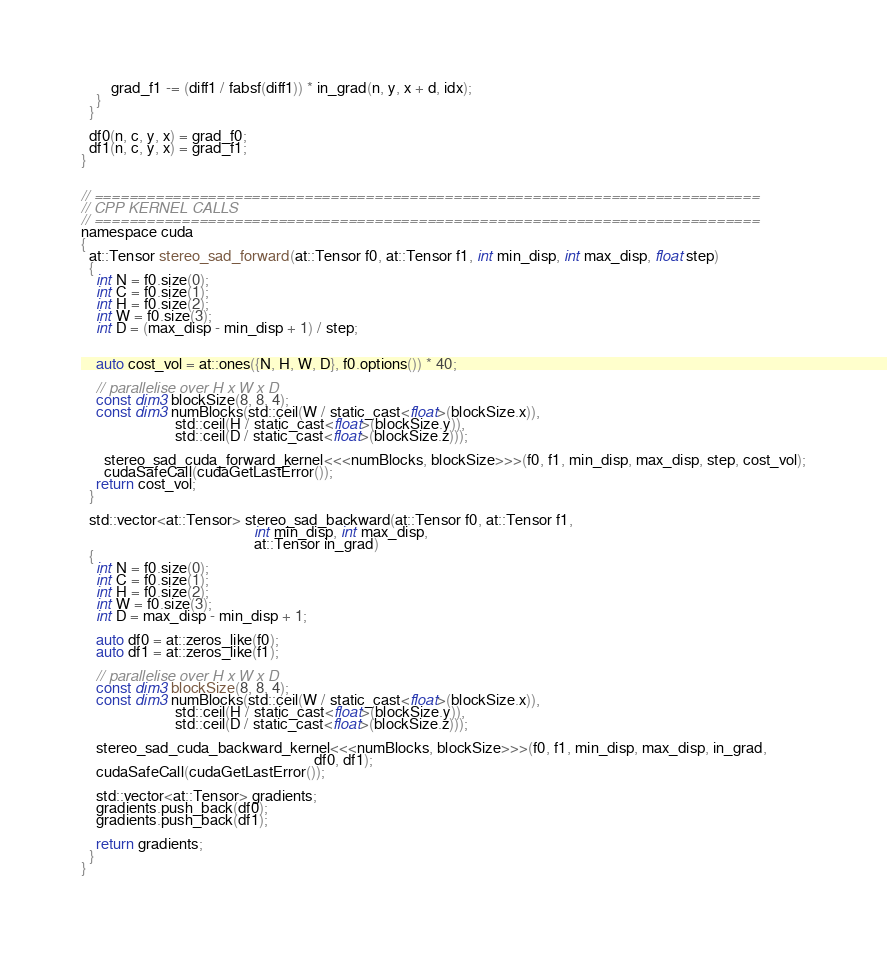Convert code to text. <code><loc_0><loc_0><loc_500><loc_500><_Cuda_>        grad_f1 -= (diff1 / fabsf(diff1)) * in_grad(n, y, x + d, idx);
    }
  }

  df0(n, c, y, x) = grad_f0;
  df1(n, c, y, x) = grad_f1;
}


// ============================================================================
// CPP KERNEL CALLS
// ============================================================================
namespace cuda
{
  at::Tensor stereo_sad_forward(at::Tensor f0, at::Tensor f1, int min_disp, int max_disp, float step)
  {
    int N = f0.size(0);
    int C = f0.size(1);
    int H = f0.size(2);
    int W = f0.size(3);
    int D = (max_disp - min_disp + 1) / step;


    auto cost_vol = at::ones({N, H, W, D}, f0.options()) * 40;

    // parallelise over H x W x D
    const dim3 blockSize(8, 8, 4);
    const dim3 numBlocks(std::ceil(W / static_cast<float>(blockSize.x)),
                         std::ceil(H / static_cast<float>(blockSize.y)),
                         std::ceil(D / static_cast<float>(blockSize.z)));

      stereo_sad_cuda_forward_kernel<<<numBlocks, blockSize>>>(f0, f1, min_disp, max_disp, step, cost_vol);
      cudaSafeCall(cudaGetLastError());
    return cost_vol;
  }   

  std::vector<at::Tensor> stereo_sad_backward(at::Tensor f0, at::Tensor f1, 
                                              int min_disp, int max_disp,
                                              at::Tensor in_grad)
  {
    int N = f0.size(0);
    int C = f0.size(1);
    int H = f0.size(2);
    int W = f0.size(3);
    int D = max_disp - min_disp + 1;

    auto df0 = at::zeros_like(f0);
    auto df1 = at::zeros_like(f1);

    // parallelise over H x W x D
    const dim3 blockSize(8, 8, 4);
    const dim3 numBlocks(std::ceil(W / static_cast<float>(blockSize.x)),
                         std::ceil(H / static_cast<float>(blockSize.y)),
                         std::ceil(D / static_cast<float>(blockSize.z)));

    stereo_sad_cuda_backward_kernel<<<numBlocks, blockSize>>>(f0, f1, min_disp, max_disp, in_grad, 
                                                              df0, df1);
    cudaSafeCall(cudaGetLastError());

    std::vector<at::Tensor> gradients;
    gradients.push_back(df0);
    gradients.push_back(df1);

    return gradients;
  }            
}</code> 